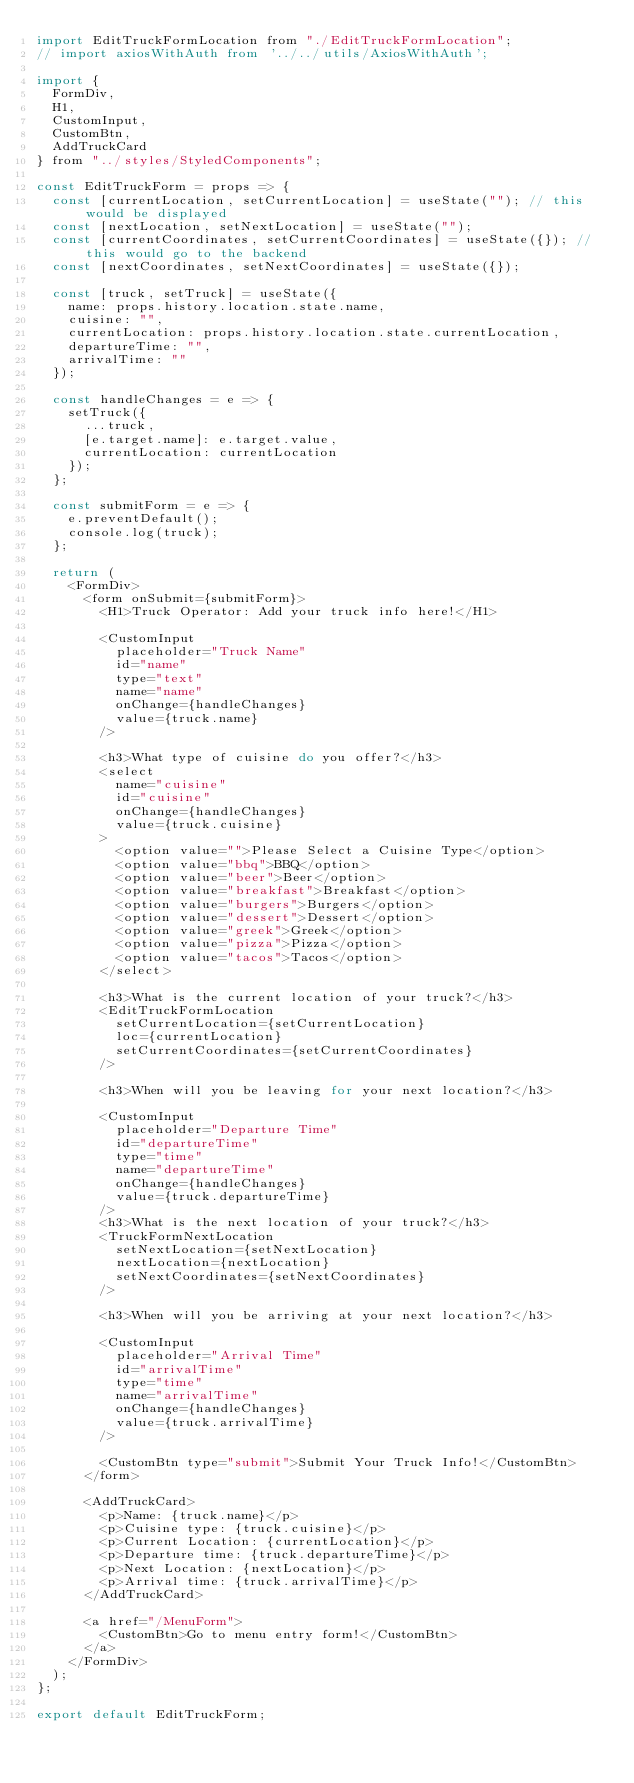<code> <loc_0><loc_0><loc_500><loc_500><_JavaScript_>import EditTruckFormLocation from "./EditTruckFormLocation";
// import axiosWithAuth from '../../utils/AxiosWithAuth';

import {
  FormDiv,
  H1,
  CustomInput,
  CustomBtn,
  AddTruckCard
} from "../styles/StyledComponents";

const EditTruckForm = props => {
  const [currentLocation, setCurrentLocation] = useState(""); // this would be displayed
  const [nextLocation, setNextLocation] = useState("");
  const [currentCoordinates, setCurrentCoordinates] = useState({}); // this would go to the backend
  const [nextCoordinates, setNextCoordinates] = useState({});

  const [truck, setTruck] = useState({
    name: props.history.location.state.name,
    cuisine: "",
    currentLocation: props.history.location.state.currentLocation,
    departureTime: "",
    arrivalTime: ""
  });

  const handleChanges = e => {
    setTruck({
      ...truck,
      [e.target.name]: e.target.value,
      currentLocation: currentLocation
    });
  };

  const submitForm = e => {
    e.preventDefault();
    console.log(truck);
  };

  return (
    <FormDiv>
      <form onSubmit={submitForm}>
        <H1>Truck Operator: Add your truck info here!</H1>

        <CustomInput
          placeholder="Truck Name"
          id="name"
          type="text"
          name="name"
          onChange={handleChanges}
          value={truck.name}
        />

        <h3>What type of cuisine do you offer?</h3>
        <select
          name="cuisine"
          id="cuisine"
          onChange={handleChanges}
          value={truck.cuisine}
        >
          <option value="">Please Select a Cuisine Type</option>
          <option value="bbq">BBQ</option>
          <option value="beer">Beer</option>
          <option value="breakfast">Breakfast</option>
          <option value="burgers">Burgers</option>
          <option value="dessert">Dessert</option>
          <option value="greek">Greek</option>
          <option value="pizza">Pizza</option>
          <option value="tacos">Tacos</option>
        </select>

        <h3>What is the current location of your truck?</h3>
        <EditTruckFormLocation
          setCurrentLocation={setCurrentLocation}
          loc={currentLocation}
          setCurrentCoordinates={setCurrentCoordinates}
        />

        <h3>When will you be leaving for your next location?</h3>

        <CustomInput
          placeholder="Departure Time"
          id="departureTime"
          type="time"
          name="departureTime"
          onChange={handleChanges}
          value={truck.departureTime}
        />
        <h3>What is the next location of your truck?</h3>
        <TruckFormNextLocation
          setNextLocation={setNextLocation}
          nextLocation={nextLocation}
          setNextCoordinates={setNextCoordinates}
        />

        <h3>When will you be arriving at your next location?</h3>

        <CustomInput
          placeholder="Arrival Time"
          id="arrivalTime"
          type="time"
          name="arrivalTime"
          onChange={handleChanges}
          value={truck.arrivalTime}
        />

        <CustomBtn type="submit">Submit Your Truck Info!</CustomBtn>
      </form>

      <AddTruckCard>
        <p>Name: {truck.name}</p>
        <p>Cuisine type: {truck.cuisine}</p>
        <p>Current Location: {currentLocation}</p>
        <p>Departure time: {truck.departureTime}</p>
        <p>Next Location: {nextLocation}</p>
        <p>Arrival time: {truck.arrivalTime}</p>
      </AddTruckCard>

      <a href="/MenuForm">
        <CustomBtn>Go to menu entry form!</CustomBtn>
      </a>
    </FormDiv>
  );
};

export default EditTruckForm;
</code> 